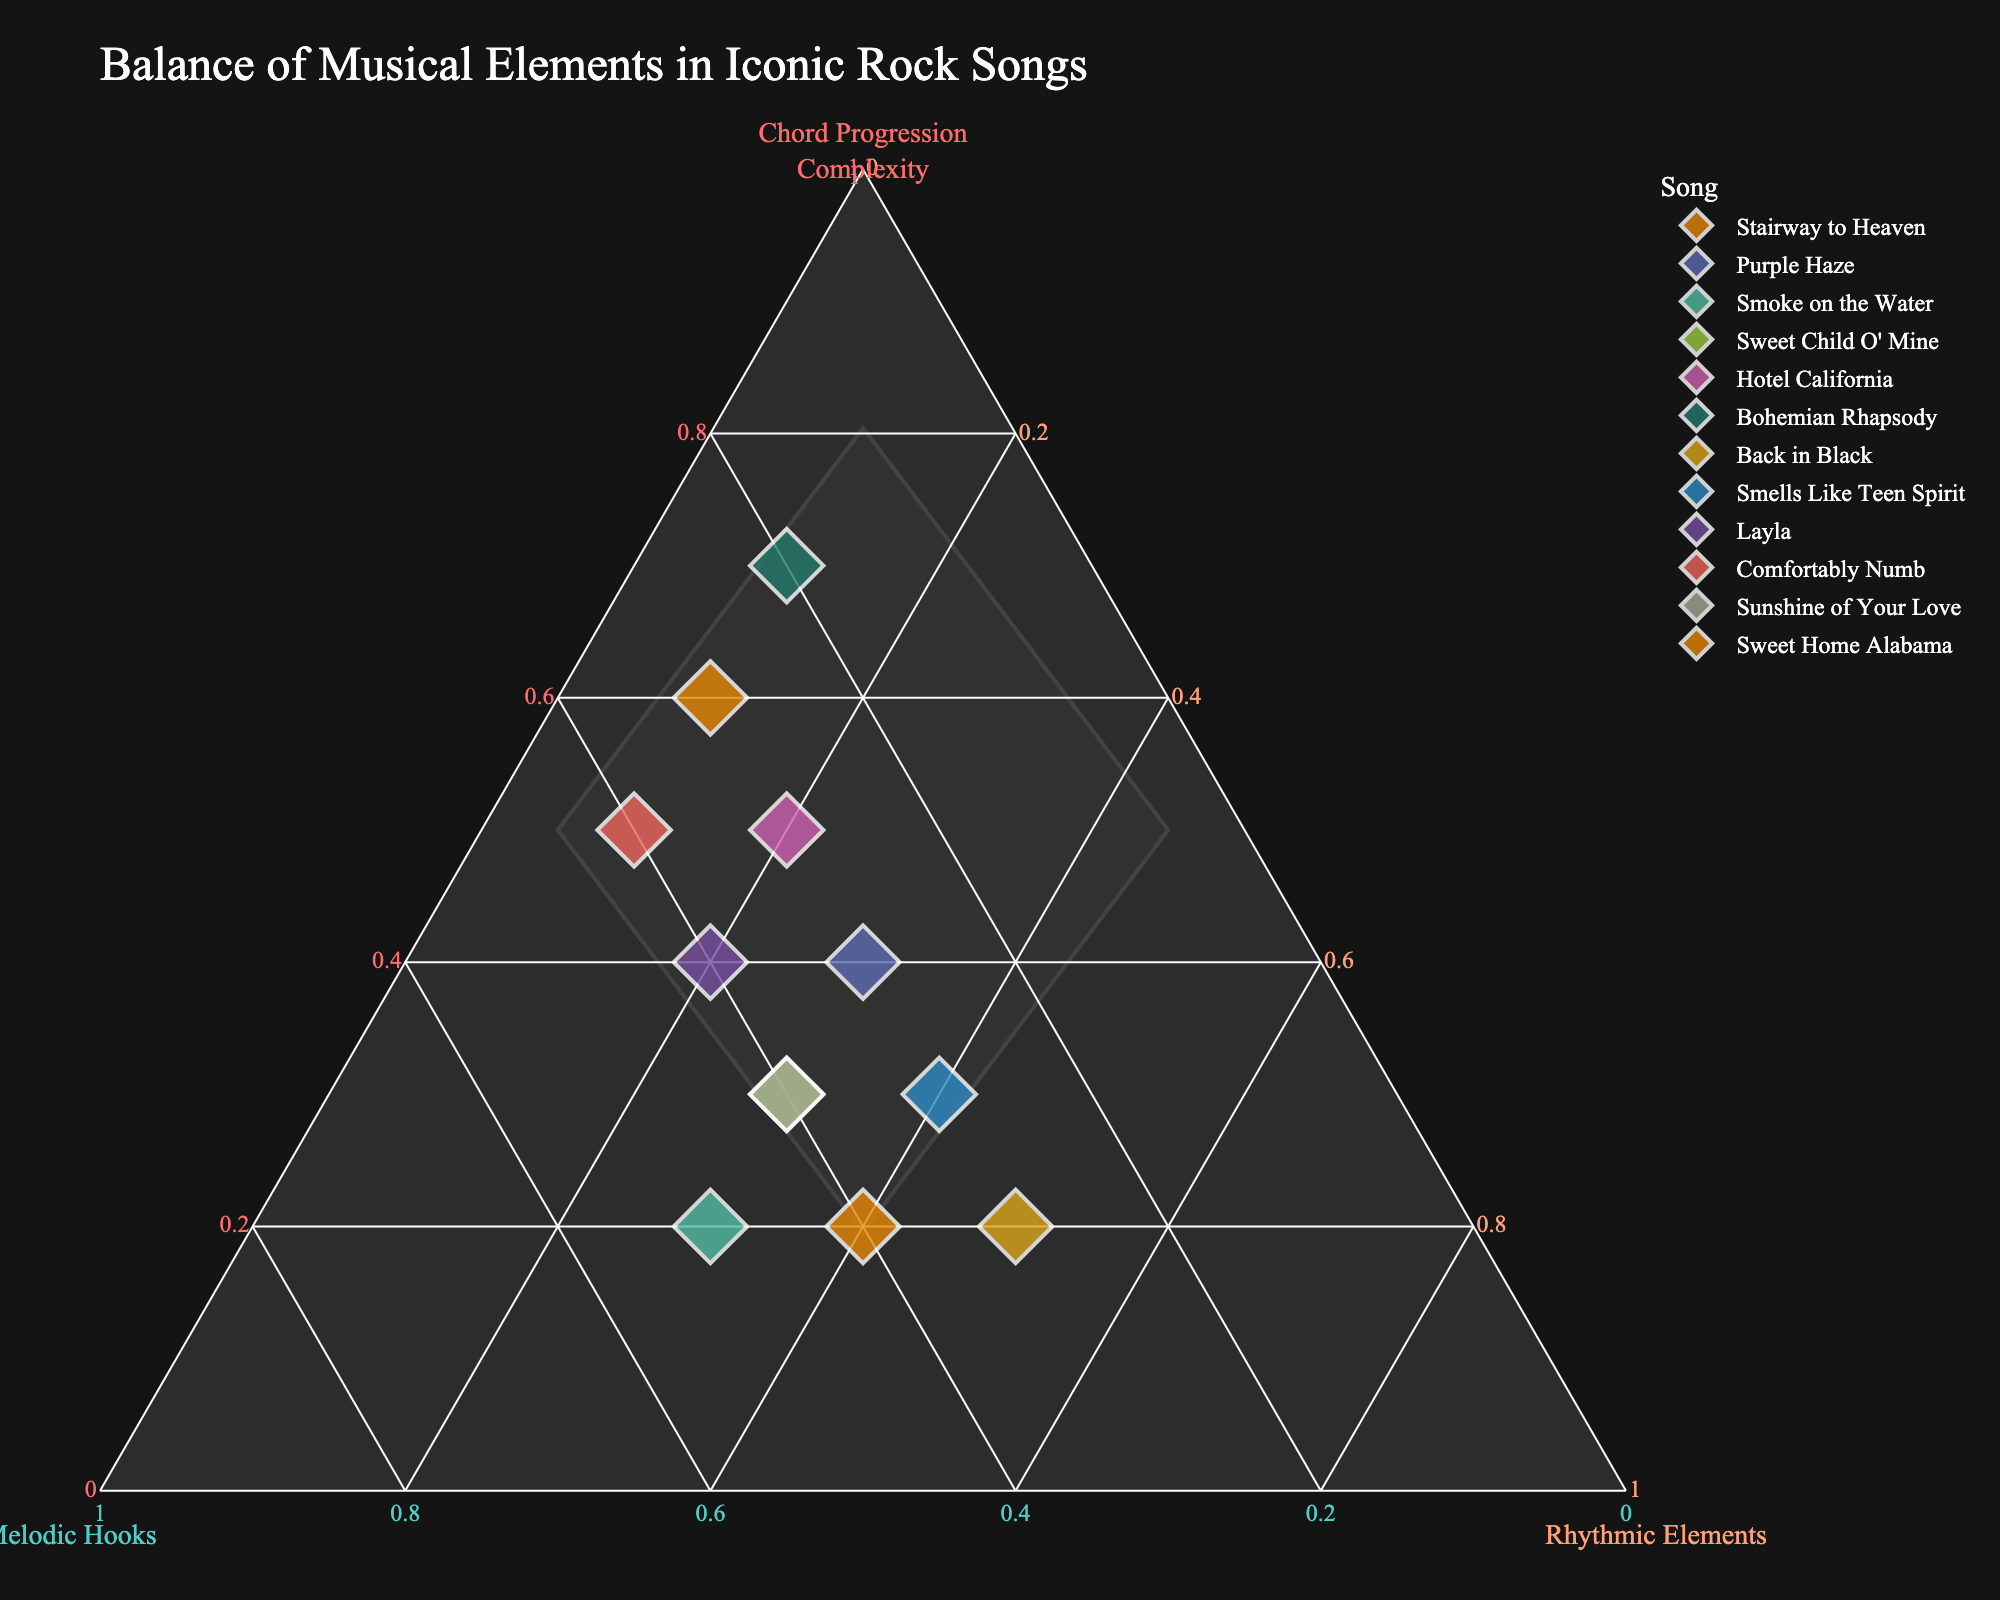what's the title of the plot? The title is typically located at the top of the plot. It provides an overview of what the plot represents. In this case, the title is "Balance of Musical Elements in Iconic Rock Songs."
Answer: Balance of Musical Elements in Iconic Rock Songs How many songs are represented in the plot? Count the distinct data points on the plot, each representing a song. In this case, there are 12 data points corresponding to 12 songs.
Answer: 12 Which song has the highest Chord Progression Complexity? Identify the data point that is furthest along the axis labeled 'Chord Progression Complexity.' Bohemian Rhapsody and Stairway to Heaven are both close, but Bohemian Rhapsody has a slightly higher value.
Answer: Bohemian Rhapsody Which song has the highest combination of Melodic Hooks and Rhythmic Elements? Calculate the sum of Melodic Hooks and Rhythmic Elements for each song and find the highest value. Smoke on the Water (0.5 + 0.3 = 0.8) and Sweet Home Alabama (0.4 + 0.4 = 0.8) both have the highest combination.
Answer: Smoke on the Water, Sweet Home Alabama What song has an equal balance of Chord Progression Complexity and Rhythmic Elements, while still having Melodic Hooks? Find a song where the values of Chord Progression Complexity and Rhythmic Elements are equal and not zero, and Melodic Hooks is present. Purple Haze has 0.4 for both Chord Progression Complexity and Rhythmic Elements and 0.3 for Melodic Hooks.
Answer: Purple Haze Which song leans most heavily on Rhythmic Elements? Locate the data point closest to the 'Rhythmic Elements' vertex. Back in Black has the highest value for Rhythmic Elements at 0.5.
Answer: Back in Black How do the Melodic Hooks compare between Layla and Comfortably Numb? Check the values for Melodic Hooks for both songs. Layla has 0.4 and Comfortably Numb also has 0.4.
Answer: They are equal Which song has the least complexity in Chord Progression? Find the song with the lowest value along the 'Chord Progression Complexity' axis. Smoke on the Water has the lowest value at 0.2.
Answer: Smoke on the Water What's the average value of Chord Progression Complexity in the plotted songs? Sum up all values for Chord Progression Complexity and divide by the number of songs: (0.6 + 0.4 + 0.2 + 0.3 + 0.5 + 0.7 + 0.2 + 0.3 + 0.4 + 0.5 + 0.3 + 0.2) / 12 = 4.6 / 12 ≈ 0.38
Answer: 0.38 